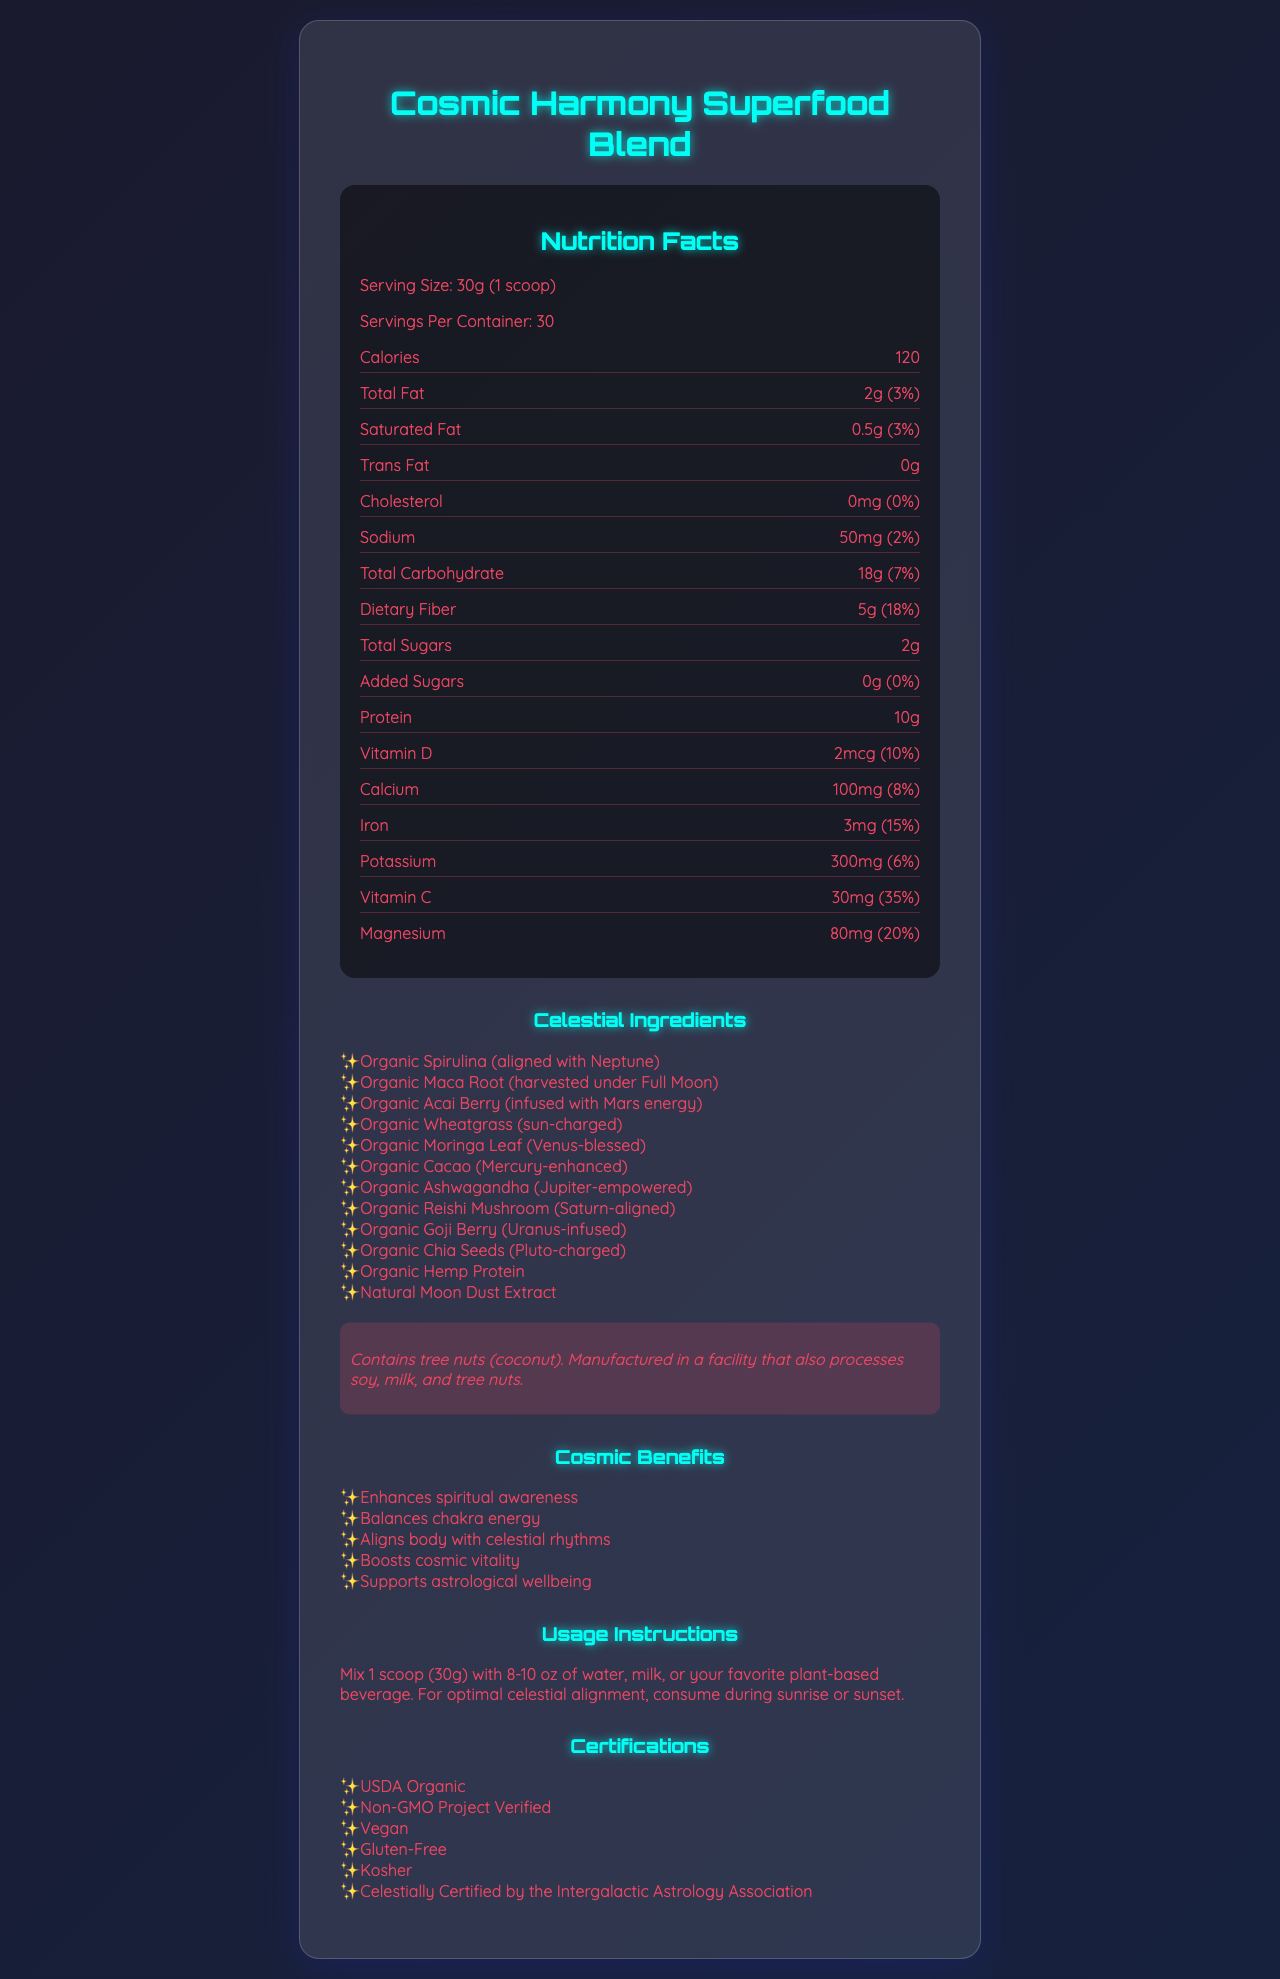who is the product manufacturer? The document does not provide the name or details of the manufacturer, so this cannot be determined.
Answer: Not enough information What is the serving size of the Cosmic Harmony Superfood Blend? The serving size is stated at the top of the Nutrition Facts section as "Serving Size: 30g (1 scoop)".
Answer: 30g (1 scoop) How many calories are there per serving? The number of calories per serving is listed in the Nutrition Facts section as "Calories: 120".
Answer: 120 calories What is the total fat per serving and its daily value percentage? The content of total fat and its daily value are listed in the Nutrition Facts section as "Total Fat: 2g (3%)".
Answer: 2g, 3% Which ingredient is aligned with Neptune? The Celestial Ingredients section lists "Organic Spirulina (aligned with Neptune)" as one of the ingredients.
Answer: Organic Spirulina Is there any trans fat in the Cosmic Harmony Superfood Blend? The Nutritional Facts section states "Trans Fat: 0g".
Answer: No What percentage of the daily value of iron is provided per serving? The daily value of iron per serving is listed in the Nutrition Facts section as "Iron: 3mg (15%)".
Answer: 15% Which of the following certifications is NOT listed for the Cosmic Harmony Superfood Blend?  
A. USDA Organic  
B. Non-GMO Project Verified  
C. Fair Trade Certified  
D. Vegan The Certifications section lists USDA Organic, Non-GMO Project Verified, Vegan, Gluten-Free, Kosher, and Celestially Certified by the Intergalactic Astrology Association, but not Fair Trade Certified.
Answer: C Which ingredient is harvested under the Full Moon?  
I. Organic Spirulina  
II. Organic Maca Root  
III. Organic Cacao The Celestial Ingredients section lists "Organic Maca Root (harvested under Full Moon)".
Answer: II Does the product contain any added sugars? The Nutrition Facts section specifies "Added Sugars: 0g (0%)".
Answer: No Summarize the main information provided in the document. The document combines visual hierarchical information including the product's nutrition facts, with sections for ingredients, benefits, usage instructions, and certifications. It presents the Cosmic Harmony Superfood Blend as a health product with spiritual and nutritional advantages.
Answer: The document is a detailed presentation of the Cosmic Harmony Superfood Blend, highlighting its nutritional content, list of unique celestial-aligned ingredients, and various certifications. It outlines the cosmic benefits of the superfood, usage instructions, and allergen information, creating an overview of how the product aligns with astrological and nutritional health. List at least two cosmic benefits mentioned in the document. The Cosmic Benefits section lists multiple benefits, including "Enhances spiritual awareness" and "Boosts cosmic vitality".
Answer: Enhances spiritual awareness, Boosts cosmic vitality Which vitamin has the highest daily value percentage per serving? The Nutrition Facts section lists the daily value percentages for various vitamins and minerals, with Vitamin C having the highest at 35%.
Answer: Vitamin C with 35% Is the product gluten-free? The Certifications section includes "Gluten-Free" among the product's certifications.
Answer: Yes 